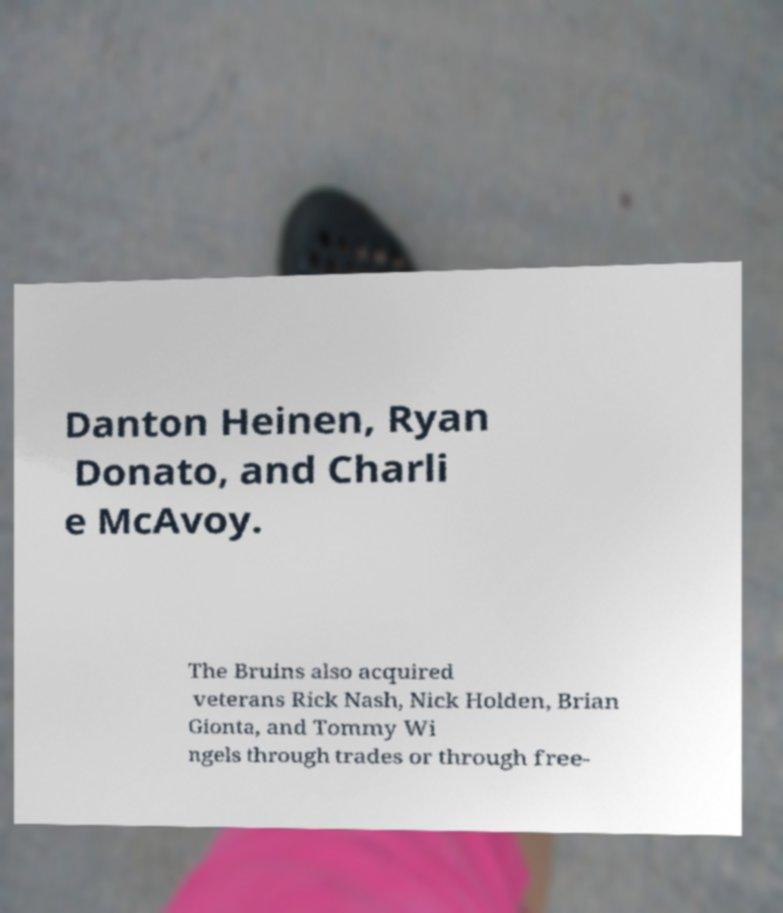There's text embedded in this image that I need extracted. Can you transcribe it verbatim? Danton Heinen, Ryan Donato, and Charli e McAvoy. The Bruins also acquired veterans Rick Nash, Nick Holden, Brian Gionta, and Tommy Wi ngels through trades or through free- 